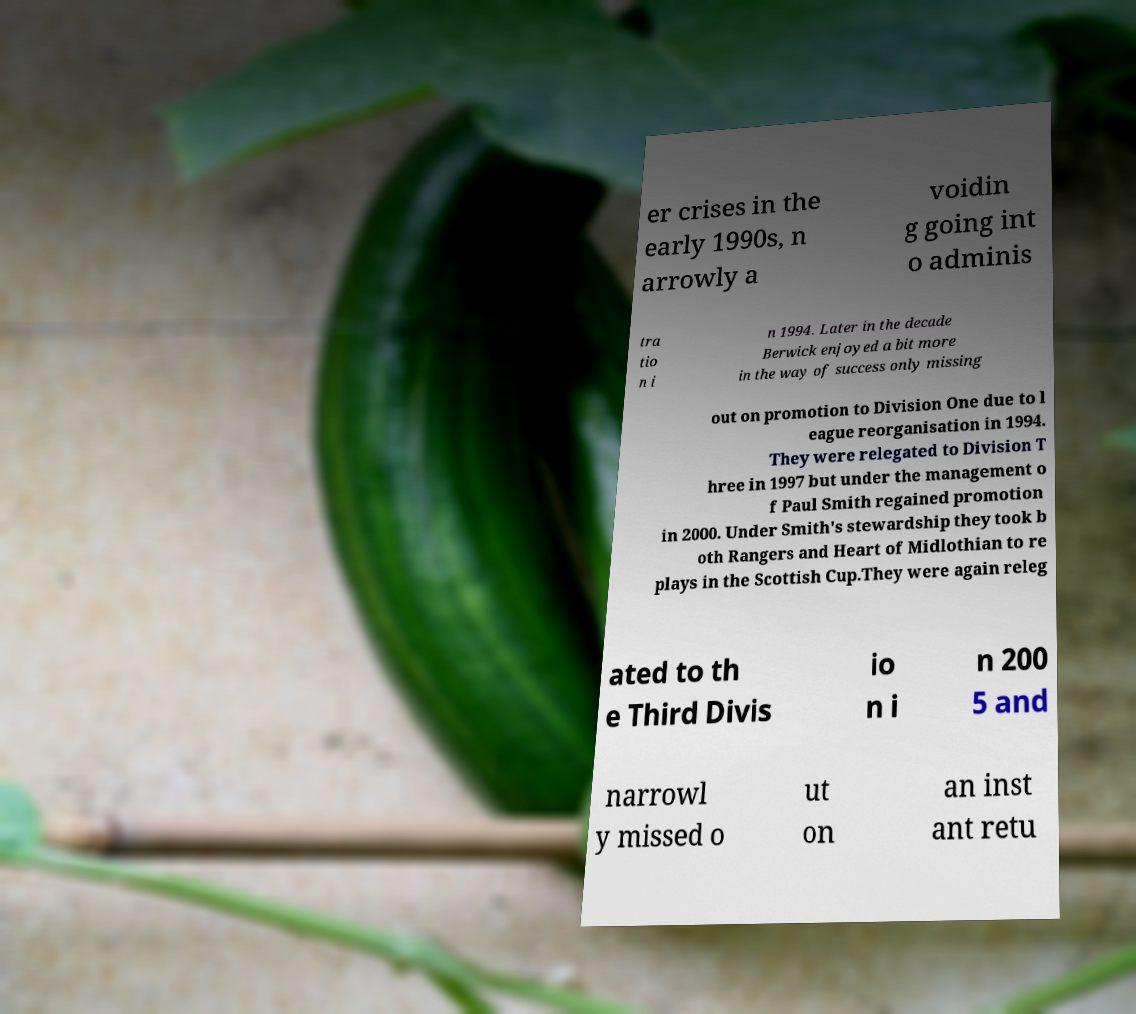Please identify and transcribe the text found in this image. er crises in the early 1990s, n arrowly a voidin g going int o adminis tra tio n i n 1994. Later in the decade Berwick enjoyed a bit more in the way of success only missing out on promotion to Division One due to l eague reorganisation in 1994. They were relegated to Division T hree in 1997 but under the management o f Paul Smith regained promotion in 2000. Under Smith's stewardship they took b oth Rangers and Heart of Midlothian to re plays in the Scottish Cup.They were again releg ated to th e Third Divis io n i n 200 5 and narrowl y missed o ut on an inst ant retu 